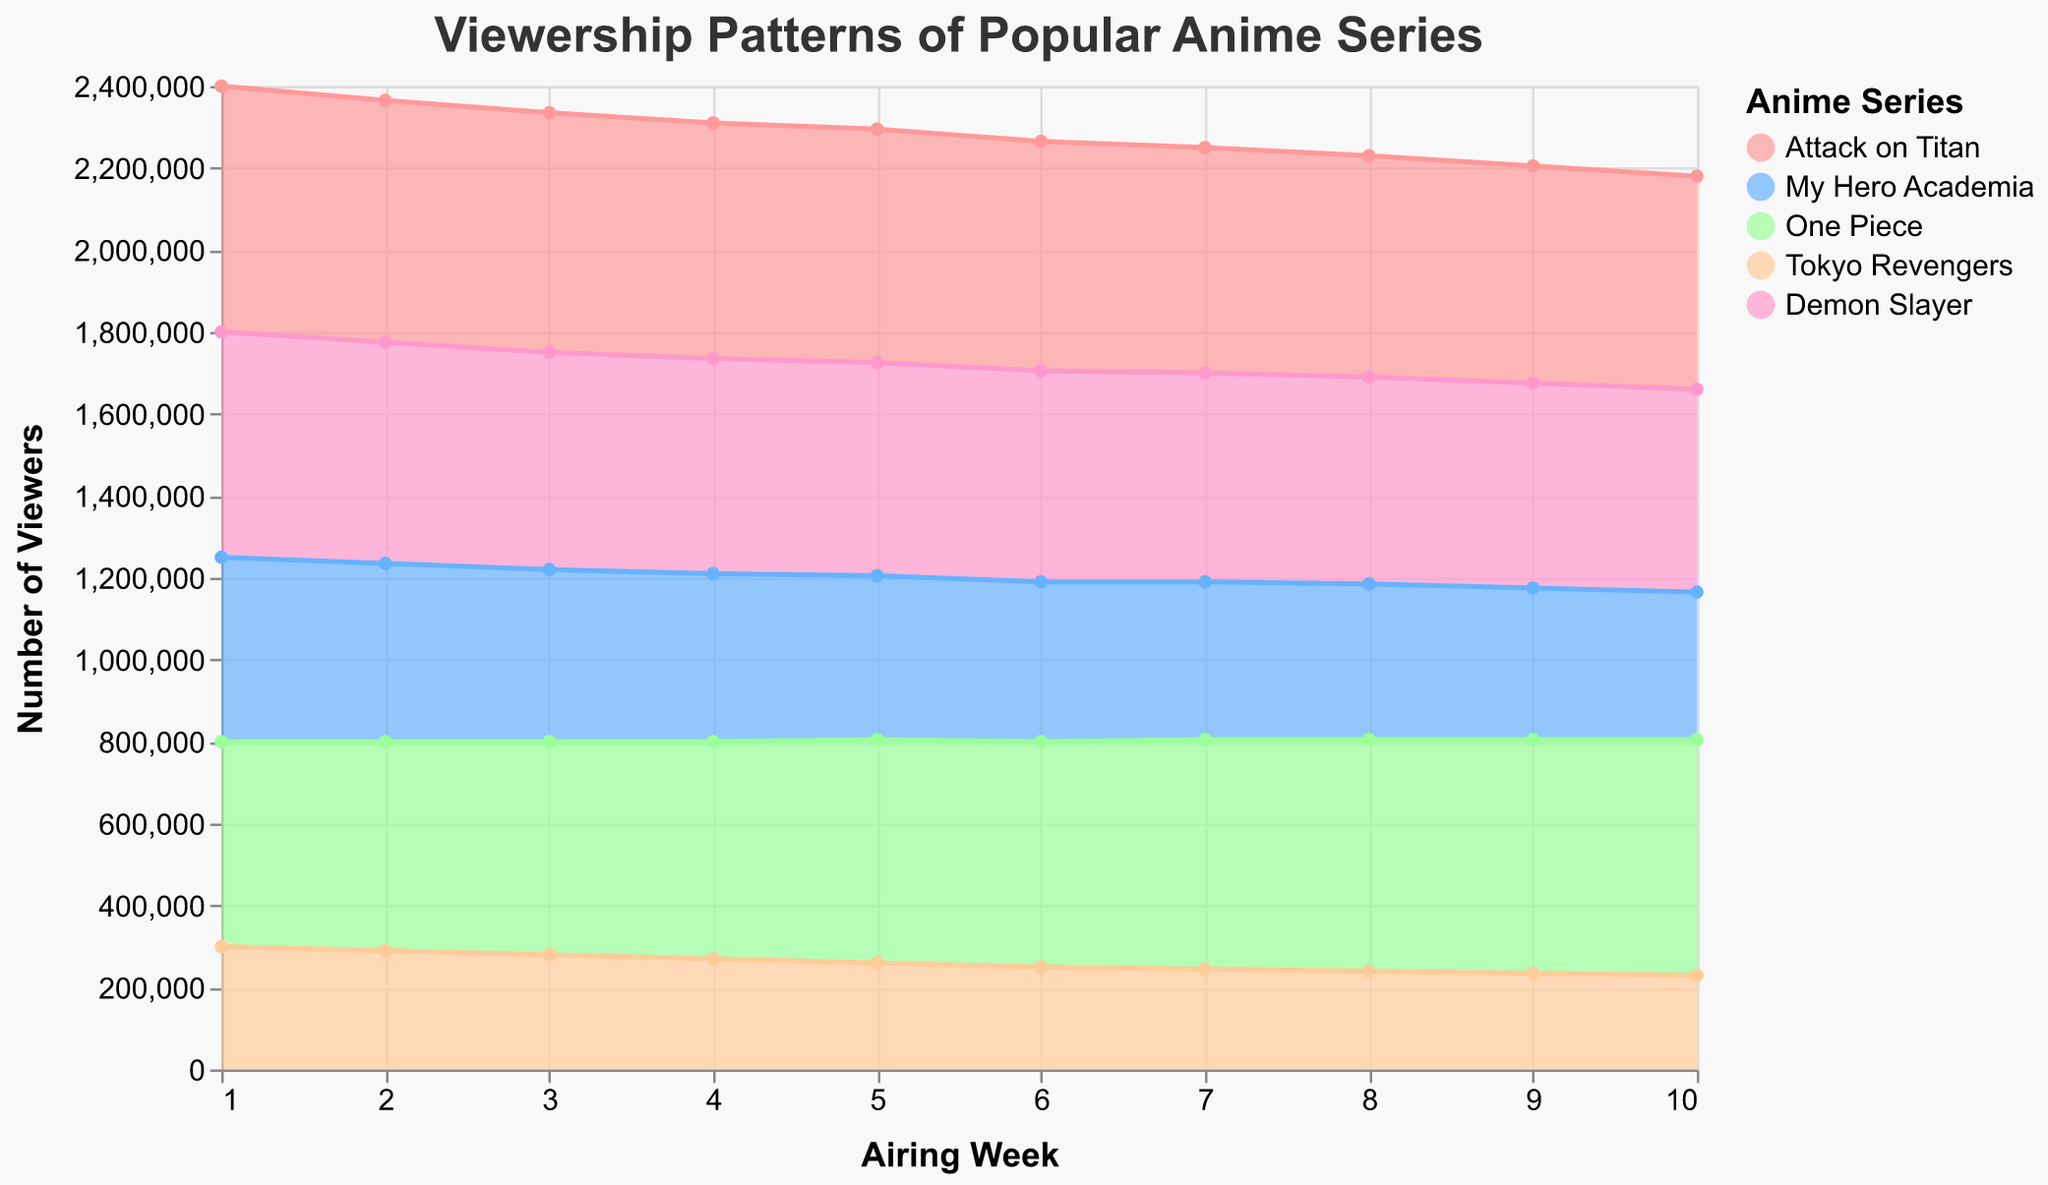What's the title of the figure? The title is displayed at the top of the figure.
Answer: Viewership Patterns of Popular Anime Series How many anime series are shown in the figure? The legend on the right side shows the names of the anime series, listed by color.
Answer: 5 Which anime had the highest viewership in Week 1? By looking at the start of the chart in Week 1 and comparing the heights of the areas, Attack on Titan reaches the highest point.
Answer: Attack on Titan What is the trend in viewership for Tokyo Revengers from Week 1 to Week 10? Observing the area representing Tokyo Revengers (color-coded) from Week 1 to Week 10 shows a consistent decline in viewership.
Answer: Declining What is the total viewership for My Hero Academia in Week 5 and Week 6? Summing the viewership values for My Hero Academia in Week 5 (400,000) and Week 6 (390,000).
Answer: 790,000 Which anime had the smallest drop in viewership from Week 1 to Week 10? By comparing the viewership values from Week 1 to Week 10 for all anime, One Piece had the smallest drop from 500,000 to 575,000 (an increase actually).
Answer: One Piece Which week had the highest total combined viewership for all anime series? To answer, calculate the sum of viewerships for all anime in each week and find the week with the highest sum. Week 1 has the highest combined viewership total after summing values.
Answer: Week 1 What's the average viewership of Demon Slayer over the entire 10 weeks? Summing viewership for Demon Slayer for all weeks (550,000 + 540,000 + 530,000 + 525,000 + 520,000 + 515,000 + 510,000 + 505,000 + 500,000 + 495,000) and dividing by 10.
Answer: 519,000 In which week did One Piece surpass Attack on Titan in viewership? Compare the viewership values of One Piece and Attack on Titan for each week, and identify the week when One Piece's value exceeds Attack on Titan's.
Answer: Week 5 Is there any week where the viewership of all anime series combined is less than 2 million? Sum the viewership of all anime series for each week and check if any week's total is less than 2 million. No week falls below 2 million, closest being Week 10 with 2,180,000.
Answer: No 